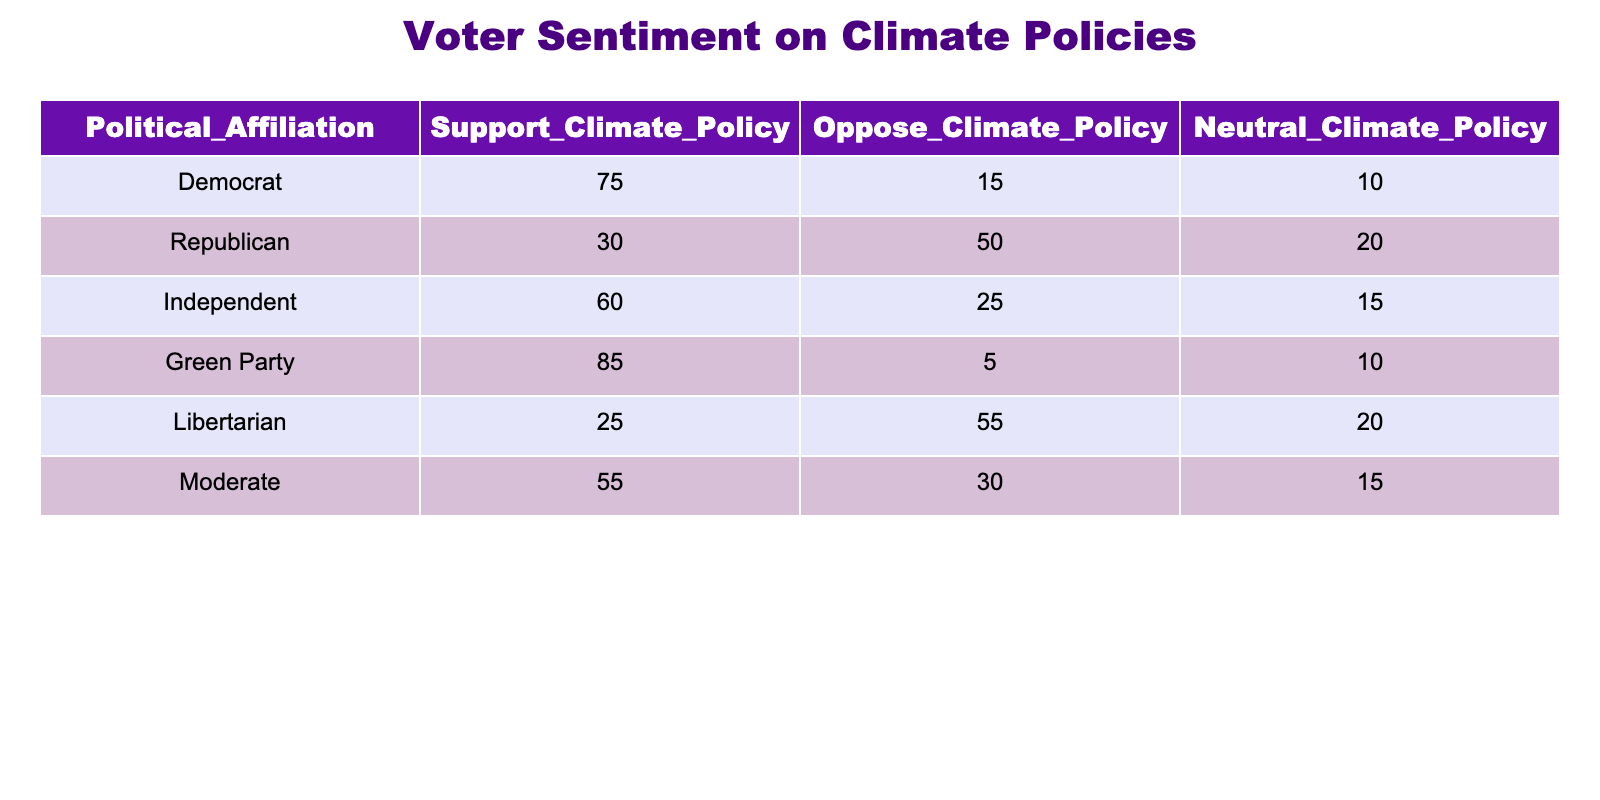What is the total number of Democrats in favor of climate policy? From the table, we see that the number of Democrats supporting climate policy is given as 75. Therefore, the total number of Democrats in favor is simply 75.
Answer: 75 What percentage of Independents are neutral about climate policy? The table shows that there are 15 Independents who are neutral out of a total of 100 Independents (60 supporters + 25 opposers + 15 neutrals). To find the percentage, we calculate (15 / 100) * 100 = 15%.
Answer: 15% Which political group has the highest support for climate policy? Looking through the "Support Climate Policy" column in the table, the Green Party shows the highest number with 85 supporters compared to other groups.
Answer: Green Party Is it true that more Republicans oppose climate policy than support it? Yes, the table indicates that 50 Republicans oppose climate policy while only 30 support it. This confirms that opposition is greater than support among Republicans.
Answer: Yes What is the average number of supporters for climate policy among all political affiliations? To find the average, we sum the number of supporters: 75 (Democrat) + 30 (Republican) + 60 (Independent) + 85 (Green Party) + 25 (Libertarian) + 55 (Moderate) = 330. There are 6 affiliations, so the average is 330 / 6 = 55.
Answer: 55 How many more Libertarians oppose climate policy than support it? The table lists 25 Libertarians in support and 55 opposed to climate policy. The difference is found by subtracting supporters from opposers: 55 - 25 = 30. Thus, there are 30 more Libertarians opposing than supporting climate policy.
Answer: 30 Which political affiliation has the least neutral sentiment towards climate policy? By inspecting the "Neutral Climate Policy" column, we see that the Green Party has the least number of neutrals with just 10 individuals.
Answer: Green Party What is the total number of respondents who either support or oppose climate policies across all affiliations? The total for supporters is 75 + 30 + 60 + 85 + 25 + 55 = 330 and for opposers is 15 + 50 + 25 + 5 + 55 + 30 = 180. Therefore, adding both together gives us a total of 330 + 180 = 510.
Answer: 510 How many more Democrats are neutral than Republicans? The number of Democrats who are neutral is 10, while Republicans who are neutral is 20. The difference is 10 (Democrats) - 20 (Republicans) = -10. This indicates there are more Republicans than Democrats who are neutral by 10.
Answer: -10 